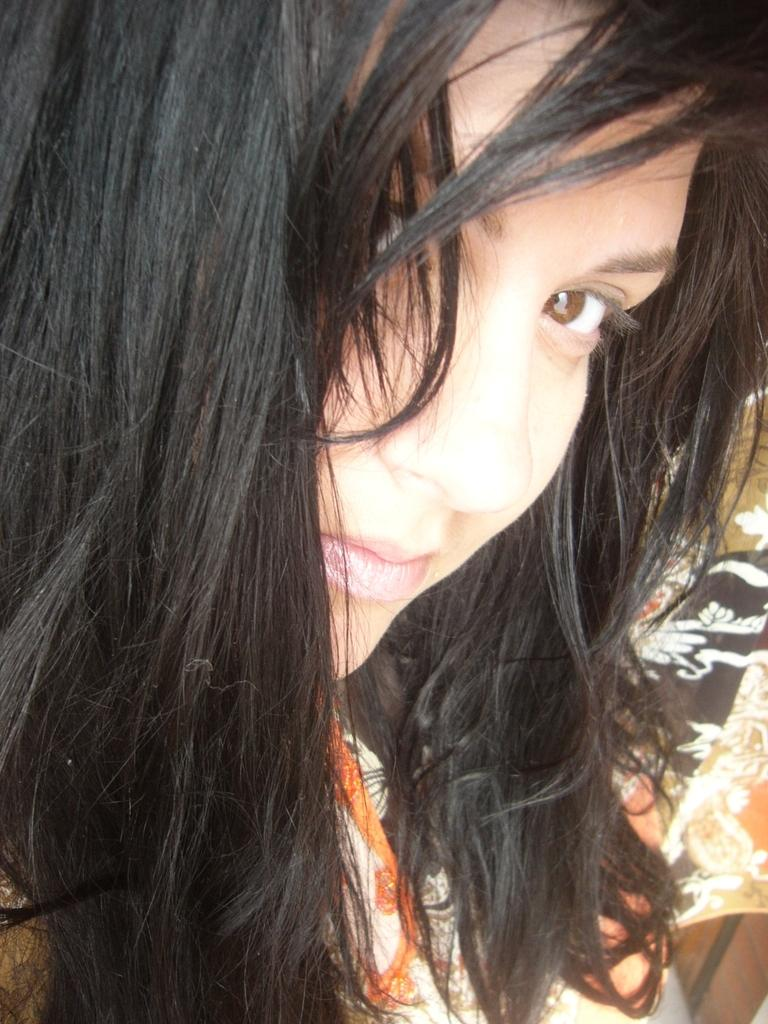What is the main subject of the image? The main subject of the image is a girl. Can you describe the girl's appearance in the image? The image is a close-up of the girl, so we cannot see her entire appearance. However, we know that she is wearing clothes. What type of furniture is visible in the image? There is no furniture visible in the image; it is a close-up of a girl. Is the girl attending school in the image? There is no indication of the girl attending school in the image, as it is a close-up of her face and does not show any school-related context. 